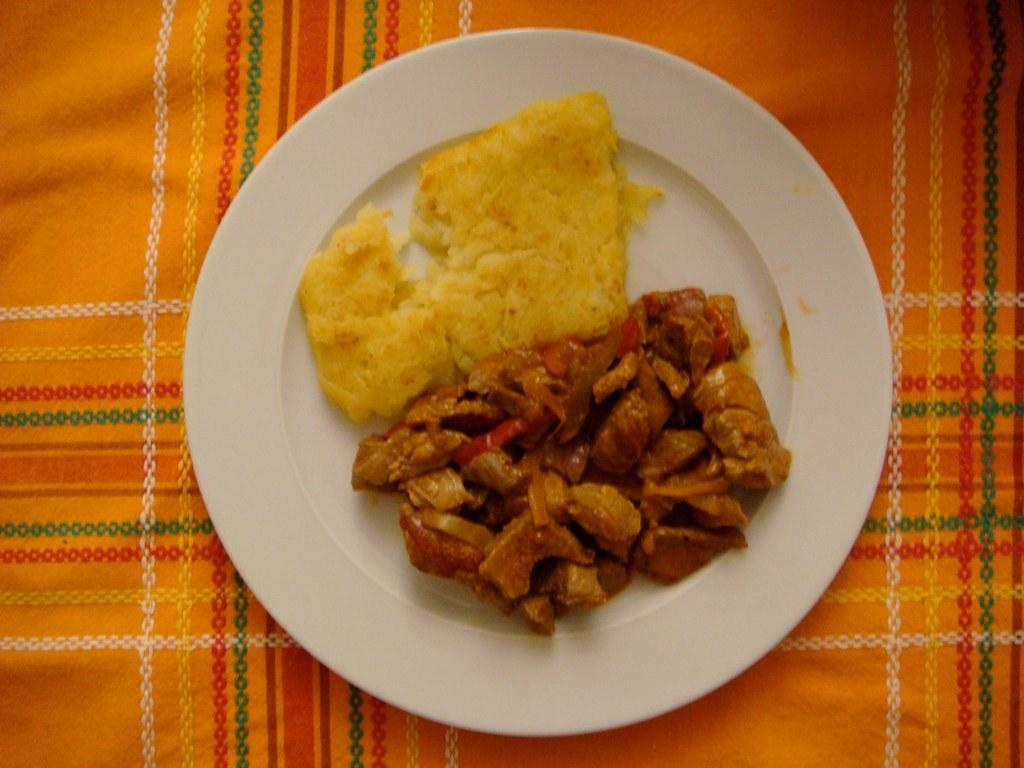What is on the plate that is visible in the image? There is a plate with food in the image. What is the plate placed on? The plate is placed on a cloth. How does the cloth shake in the image? The cloth does not shake in the image; it is stationary and serves as a surface for the plate. 